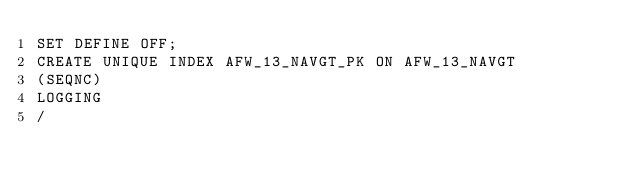Convert code to text. <code><loc_0><loc_0><loc_500><loc_500><_SQL_>SET DEFINE OFF;
CREATE UNIQUE INDEX AFW_13_NAVGT_PK ON AFW_13_NAVGT
(SEQNC)
LOGGING
/
</code> 